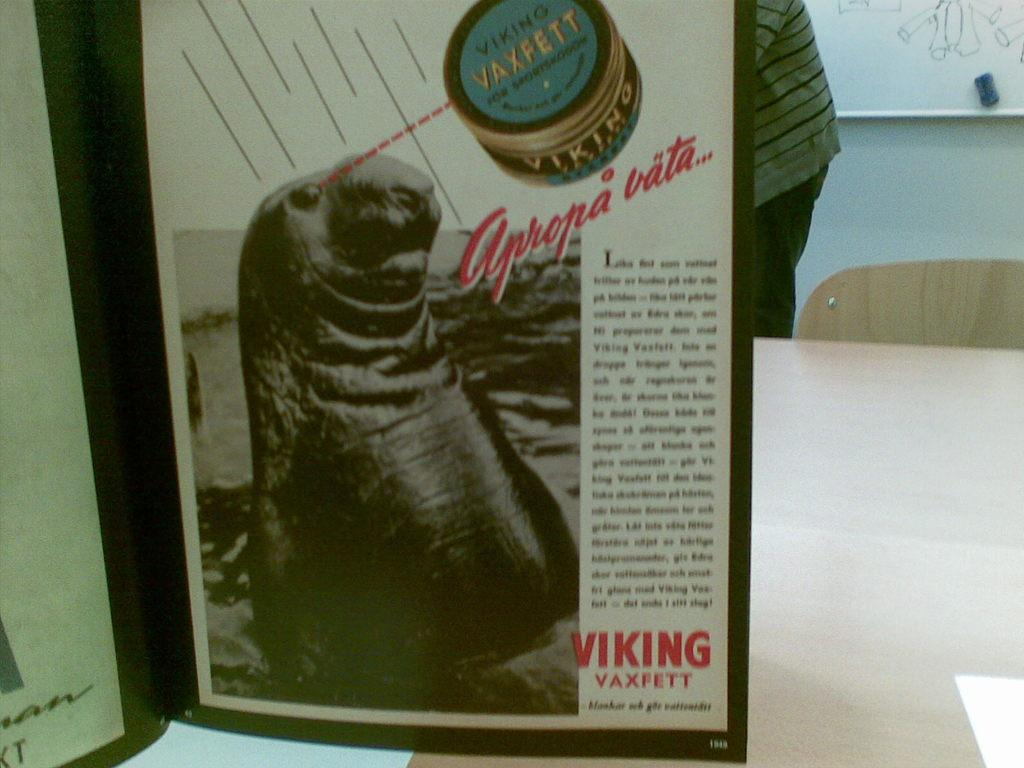<image>
Offer a succinct explanation of the picture presented. The seal has a dashed line from it's eye to the VaxFett container. 